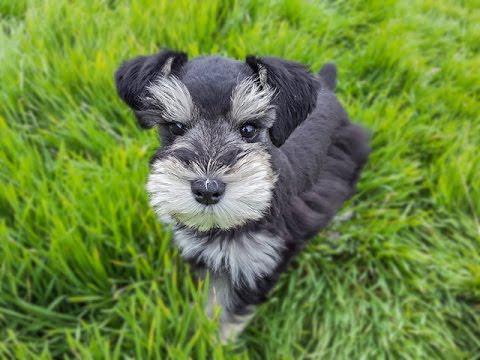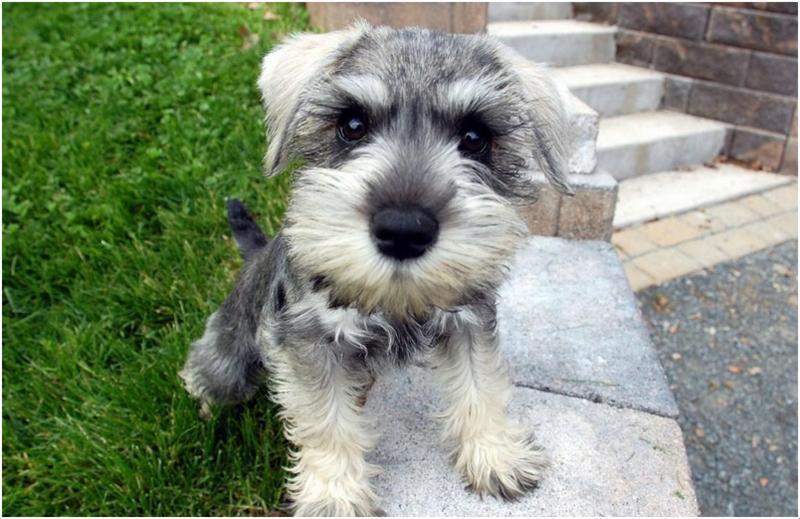The first image is the image on the left, the second image is the image on the right. Evaluate the accuracy of this statement regarding the images: "In 1 of the images, 1 dog has an object in its mouth.". Is it true? Answer yes or no. No. The first image is the image on the left, the second image is the image on the right. For the images displayed, is the sentence "All images show dogs outdoors with grass." factually correct? Answer yes or no. Yes. 